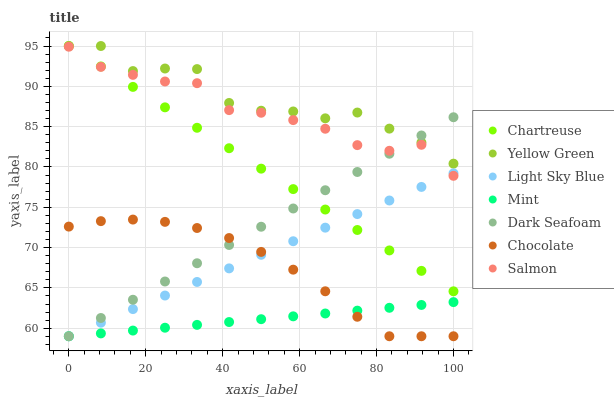Does Mint have the minimum area under the curve?
Answer yes or no. Yes. Does Yellow Green have the maximum area under the curve?
Answer yes or no. Yes. Does Salmon have the minimum area under the curve?
Answer yes or no. No. Does Salmon have the maximum area under the curve?
Answer yes or no. No. Is Chartreuse the smoothest?
Answer yes or no. Yes. Is Yellow Green the roughest?
Answer yes or no. Yes. Is Salmon the smoothest?
Answer yes or no. No. Is Salmon the roughest?
Answer yes or no. No. Does Dark Seafoam have the lowest value?
Answer yes or no. Yes. Does Salmon have the lowest value?
Answer yes or no. No. Does Chartreuse have the highest value?
Answer yes or no. Yes. Does Salmon have the highest value?
Answer yes or no. No. Is Mint less than Chartreuse?
Answer yes or no. Yes. Is Yellow Green greater than Salmon?
Answer yes or no. Yes. Does Chartreuse intersect Dark Seafoam?
Answer yes or no. Yes. Is Chartreuse less than Dark Seafoam?
Answer yes or no. No. Is Chartreuse greater than Dark Seafoam?
Answer yes or no. No. Does Mint intersect Chartreuse?
Answer yes or no. No. 